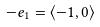Convert formula to latex. <formula><loc_0><loc_0><loc_500><loc_500>- e _ { 1 } = \langle - 1 , 0 \rangle</formula> 